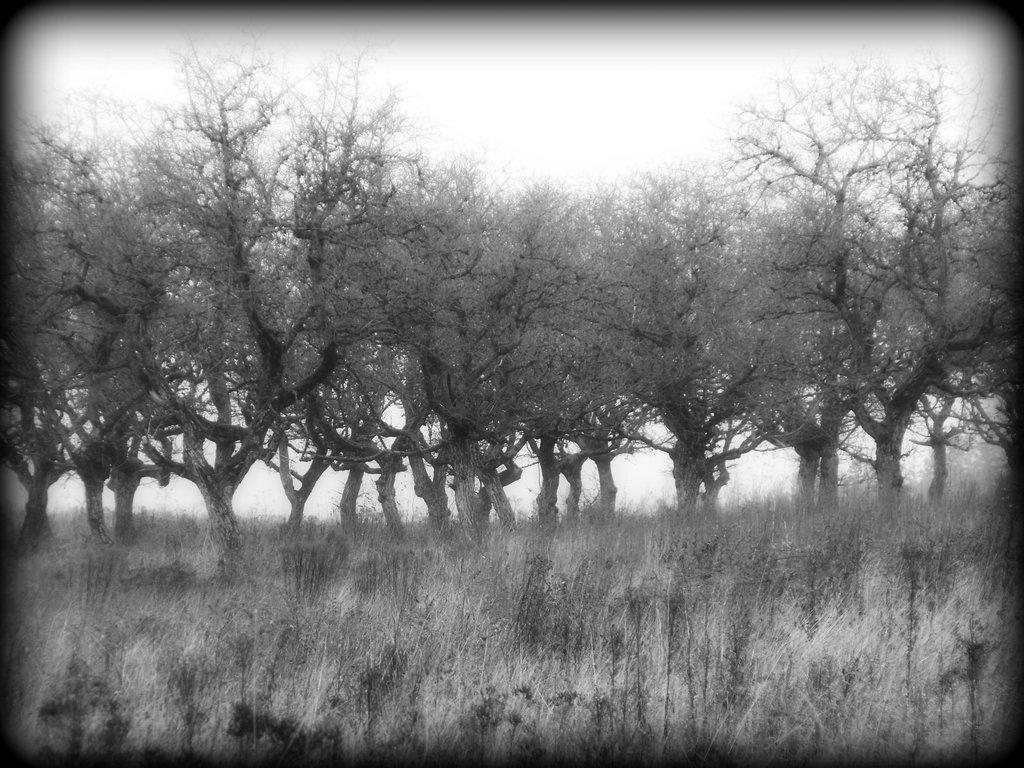What is the color scheme of the image? The image is black and white. What type of vegetation can be seen in the image? There are trees in the image. What type of ground surface is visible in the image? There is a lawn in the image. What objects are present in the image that might be used for drinking? There are straws in the image. What is visible at the top of the image? The sky is visible in the image. What shape are the ants in the image? There are no ants present in the image. How does the wind affect the trees in the image? There is no indication of wind in the image, and therefore its effect on the trees cannot be determined. 